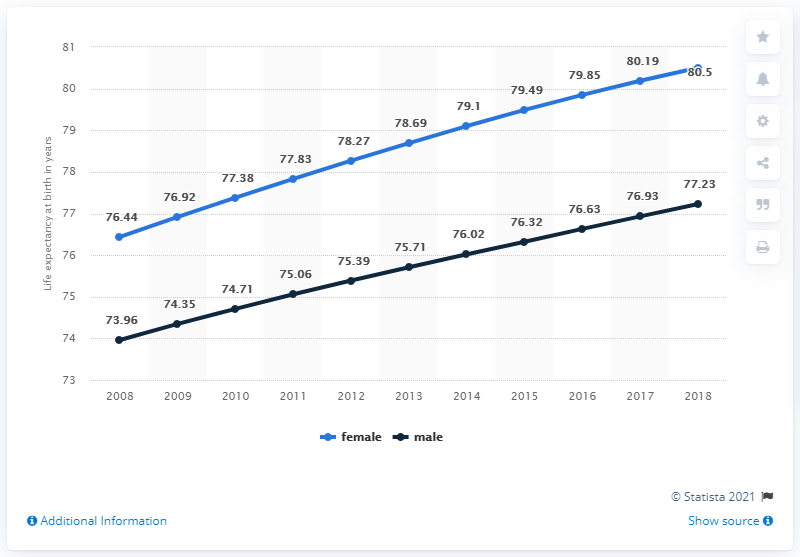Identify some key points in this picture. In 2018, the average amount of female data was 80.5%. From 2008 to 2018, the male data increased by 3.27 points. 